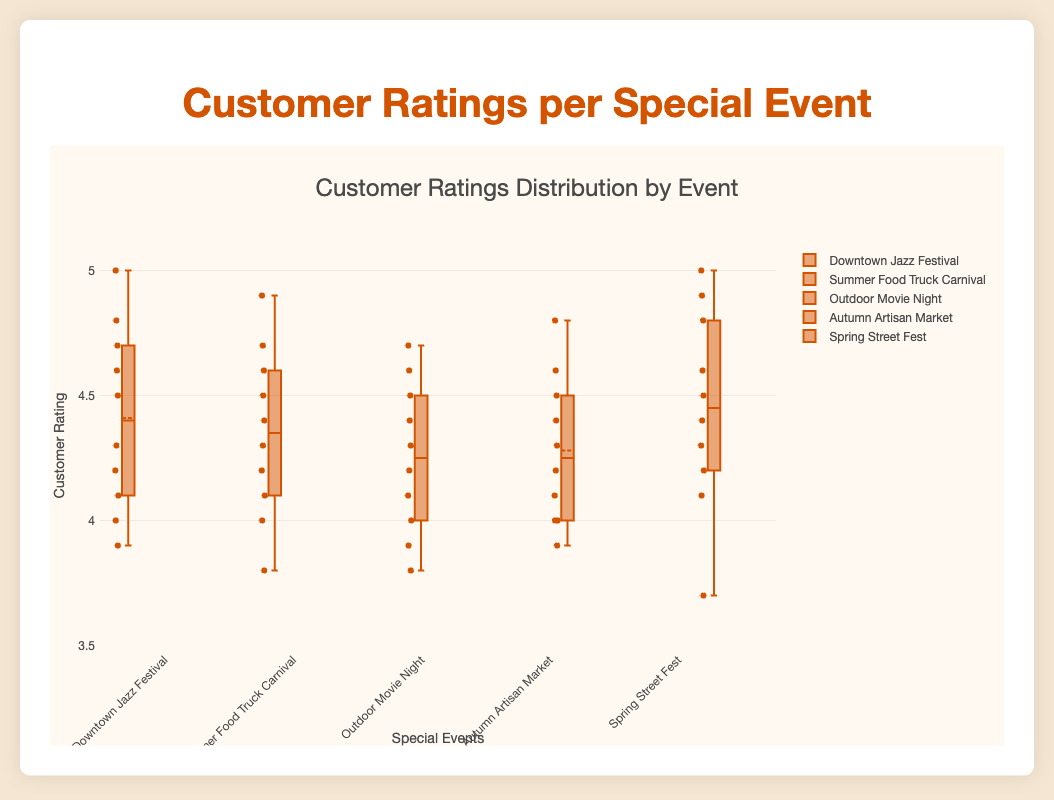Which event has the highest median customer rating? The median value is represented by the line inside the box of each box plot. By examining each event's box plot, the Spring Street Fest has the highest median line.
Answer: Spring Street Fest What's the range of customer ratings for the Summer Food Truck Carnival? The range is calculated by subtracting the minimum value from the maximum value. For Summer Food Truck Carnival, the minimum is 3.8 and the maximum is 4.9. Therefore, 4.9 - 3.8 = 1.1.
Answer: 1.1 Which event shows the most consistent customer ratings (smallest spread)? Consistency relates to how compact the data points are. The event with the smallest interquartile range (height of the box) shows the most consistent ratings. Downtown Jazz Festival has a very tight interquartile range.
Answer: Downtown Jazz Festival Are there any outliers in the Outdoor Movie Night customer ratings? Outliers in a box plot are shown as individual points outside the whiskers. For Outdoor Movie Night, there are no individual points outside the whiskers indicating no outliers.
Answer: No Which event has the highest maximum customer rating and what is it? The highest maximum point on the y-axis for the event box plots represents the highest customer rating. Spring Street Fest has the highest point at 5.0.
Answer: Spring Street Fest, 5.0 How many events had a median rating below 4.5? The median line inside the box indicates the median rating. For events below 4.5, check the line's position relative to 4.5 on the y-axis. Outdoor Movie Night, Autumn Artisan Market, and Downtown Jazz Festival all have median lines below 4.5.
Answer: Three Which event has the lowest customer rating, and what is the value? The lowest customer rating corresponds to the lowest point of the whisker. The lowest rating across all events is 3.7, found at Spring Street Fest.
Answer: Spring Street Fest, 3.7 What is the interquartile range (IQR) for Autumn Artisan Market? The IQR is the difference between the third quartile (top of the box) and the first quartile (bottom of the box). For Autumn Artisan Market, the first quartile is approximately 4.0, and the third quartile is about 4.5. So, 4.5 - 4.0 = 0.5.
Answer: 0.5 Do any events have both a minimum rating and a maximum rating at 5? All whiskers should be checked to see if any extend to the highest possible value of 5. Only Spring Street Fest has a maximum rating of 5, and there are no events with a minimum rating of 5.
Answer: No 